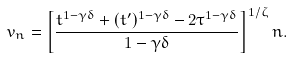Convert formula to latex. <formula><loc_0><loc_0><loc_500><loc_500>v _ { n } = \left [ \frac { t ^ { 1 - \gamma \delta } + ( t ^ { \prime } ) ^ { 1 - \gamma \delta } - 2 \tau ^ { 1 - \gamma \delta } } { 1 - \gamma \delta } \right ] ^ { 1 / \zeta } n .</formula> 